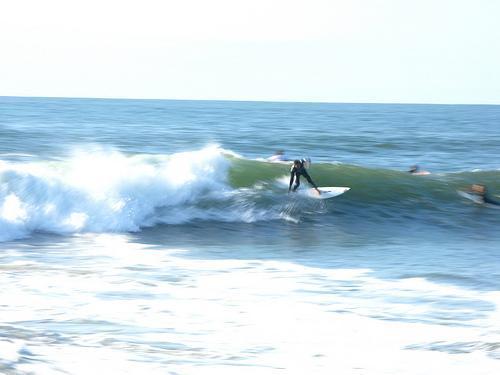How many people are up on the wave?
Give a very brief answer. 1. 